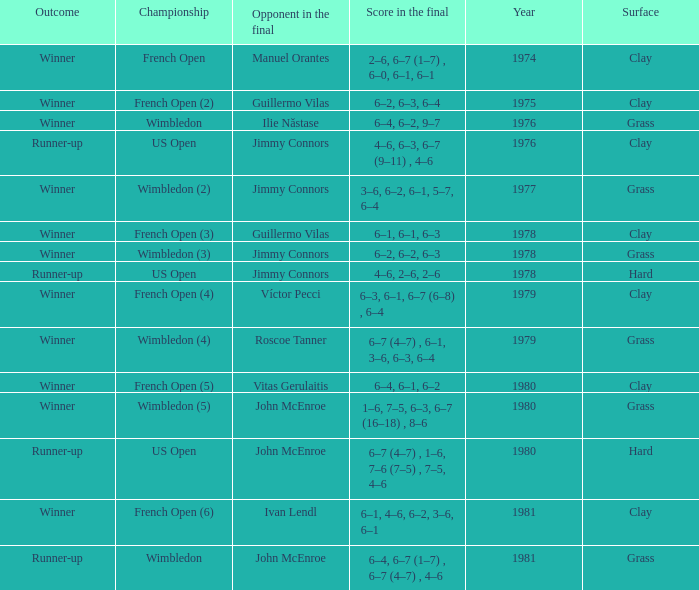What is every score in the final for opponent in final John Mcenroe at US Open? 6–7 (4–7) , 1–6, 7–6 (7–5) , 7–5, 4–6. 